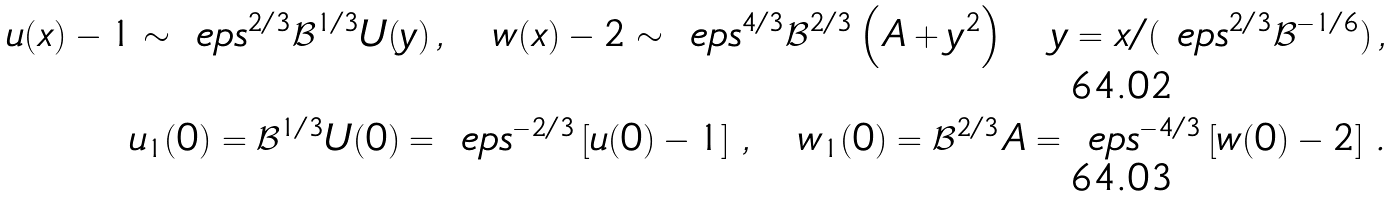<formula> <loc_0><loc_0><loc_500><loc_500>u ( x ) - 1 \sim \ e p s ^ { 2 / 3 } \mathcal { B } ^ { 1 / 3 } U ( y ) \, , \quad w ( x ) - 2 \sim \ e p s ^ { 4 / 3 } \mathcal { B } ^ { 2 / 3 } \left ( A + y ^ { 2 } \right ) \quad y = x / ( \ e p s ^ { 2 / 3 } \mathcal { B } ^ { - 1 / 6 } ) \, , \\ u _ { 1 } ( 0 ) = { \mathcal { B } } ^ { 1 / 3 } U ( 0 ) = \ e p s ^ { - 2 / 3 } \left [ u ( 0 ) - 1 \right ] \, , \quad w _ { 1 } ( 0 ) = { \mathcal { B } } ^ { 2 / 3 } A = \ e p s ^ { - 4 / 3 } \left [ w ( 0 ) - 2 \right ] \, .</formula> 